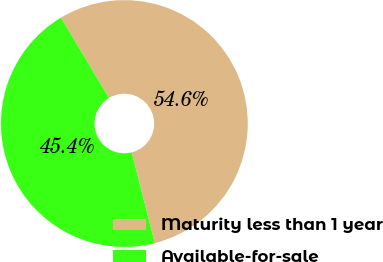Convert chart to OTSL. <chart><loc_0><loc_0><loc_500><loc_500><pie_chart><fcel>Maturity less than 1 year<fcel>Available-for-sale<nl><fcel>54.61%<fcel>45.39%<nl></chart> 